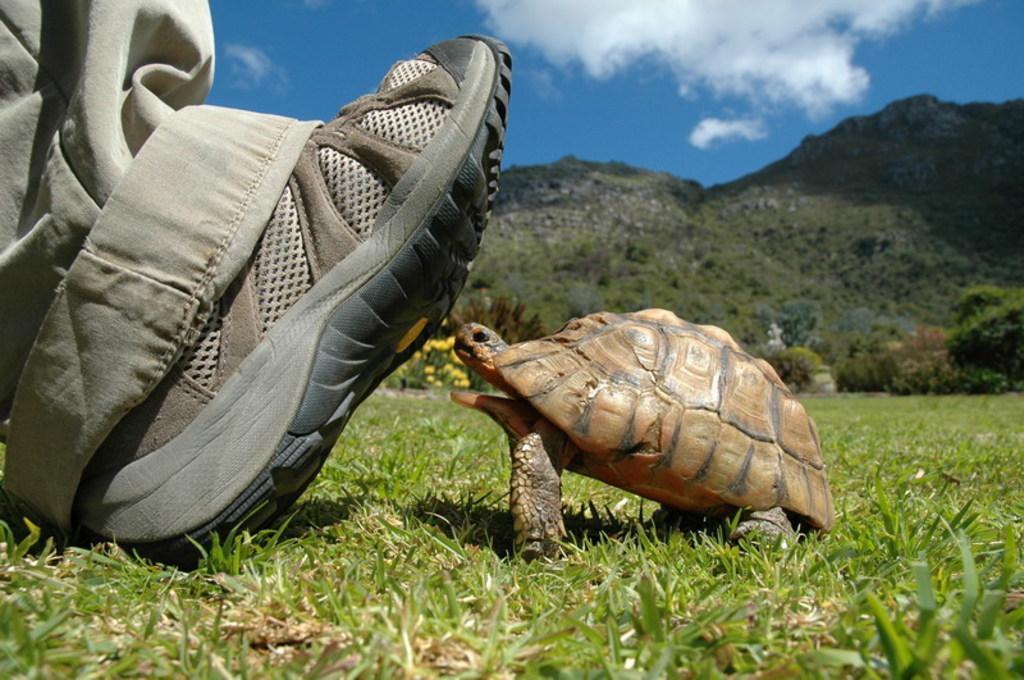Describe this image in one or two sentences. In the center of the image a tortoise is there. On the left side of the image a person leg shoe is there. In the background of the image we can see hills, trees, plants, flowers are there. At the bottom of the image grass is there. At the top of the image clouds are present in the sky. 